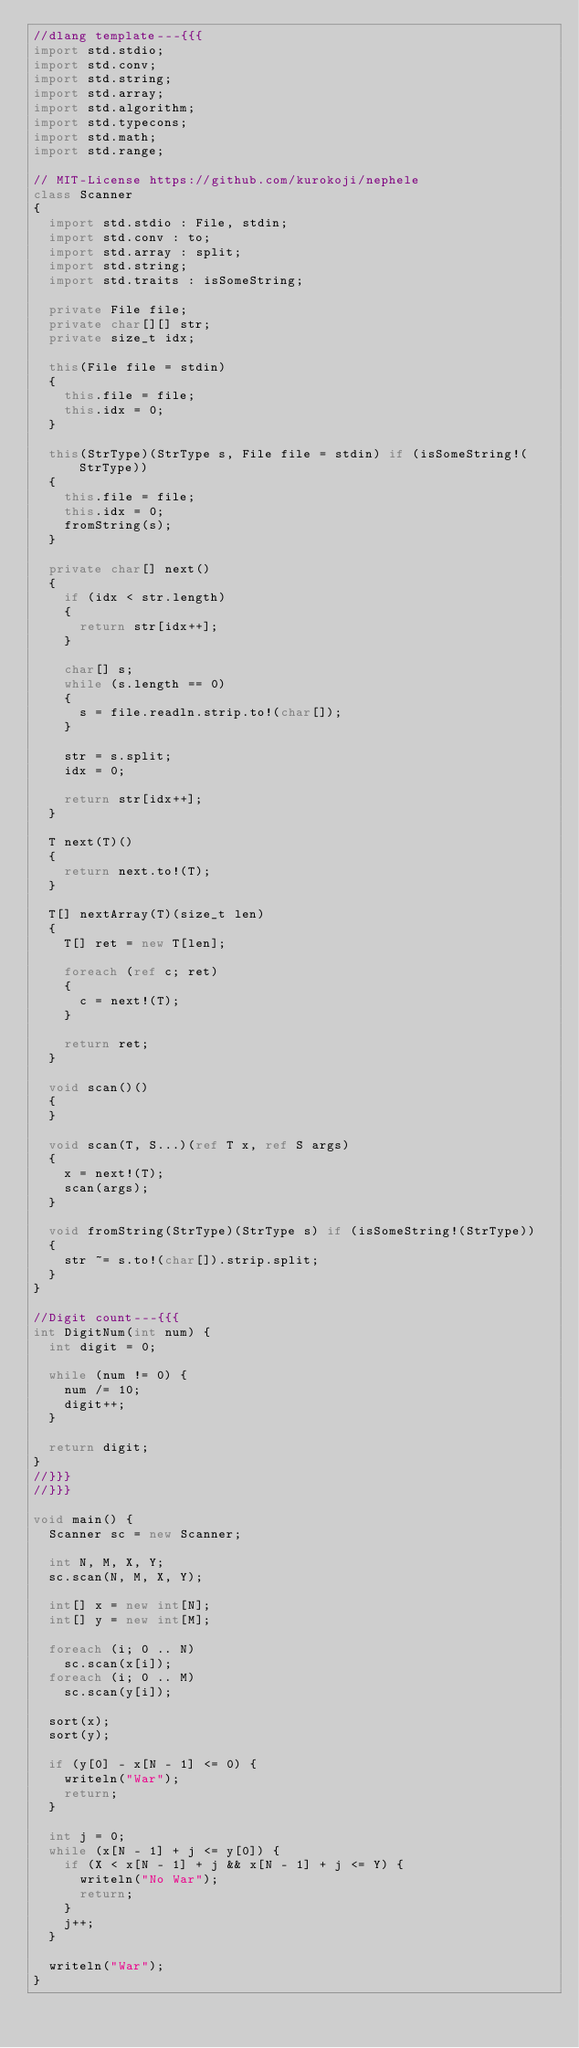<code> <loc_0><loc_0><loc_500><loc_500><_D_>//dlang template---{{{
import std.stdio;
import std.conv;
import std.string;
import std.array;
import std.algorithm;
import std.typecons;
import std.math;
import std.range;

// MIT-License https://github.com/kurokoji/nephele
class Scanner
{
  import std.stdio : File, stdin;
  import std.conv : to;
  import std.array : split;
  import std.string;
  import std.traits : isSomeString;

  private File file;
  private char[][] str;
  private size_t idx;

  this(File file = stdin)
  {
    this.file = file;
    this.idx = 0;
  }

  this(StrType)(StrType s, File file = stdin) if (isSomeString!(StrType))
  {
    this.file = file;
    this.idx = 0;
    fromString(s);
  }

  private char[] next()
  {
    if (idx < str.length)
    {
      return str[idx++];
    }

    char[] s;
    while (s.length == 0)
    {
      s = file.readln.strip.to!(char[]);
    }

    str = s.split;
    idx = 0;

    return str[idx++];
  }

  T next(T)()
  {
    return next.to!(T);
  }

  T[] nextArray(T)(size_t len)
  {
    T[] ret = new T[len];

    foreach (ref c; ret)
    {
      c = next!(T);
    }

    return ret;
  }

  void scan()()
  {
  }

  void scan(T, S...)(ref T x, ref S args)
  {
    x = next!(T);
    scan(args);
  }

  void fromString(StrType)(StrType s) if (isSomeString!(StrType))
  {
    str ~= s.to!(char[]).strip.split;
  }
}

//Digit count---{{{
int DigitNum(int num) {
  int digit = 0;

  while (num != 0) {
    num /= 10;
    digit++;
  }

  return digit;
}
//}}}
//}}}

void main() {
  Scanner sc = new Scanner;

  int N, M, X, Y;
  sc.scan(N, M, X, Y);

  int[] x = new int[N];
  int[] y = new int[M];

  foreach (i; 0 .. N)
    sc.scan(x[i]);
  foreach (i; 0 .. M)
    sc.scan(y[i]);

  sort(x);
  sort(y);

  if (y[0] - x[N - 1] <= 0) {
    writeln("War");
    return;
  }

  int j = 0;
  while (x[N - 1] + j <= y[0]) {
    if (X < x[N - 1] + j && x[N - 1] + j <= Y) {
      writeln("No War");
      return;
    }
    j++;
  }

  writeln("War");
}
</code> 